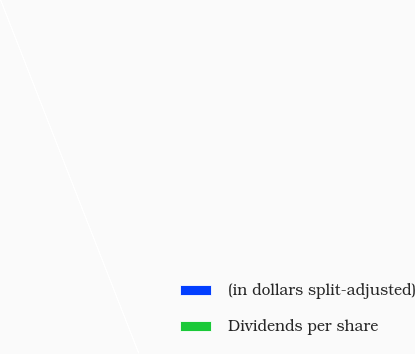<chart> <loc_0><loc_0><loc_500><loc_500><pie_chart><fcel>(in dollars split-adjusted)<fcel>Dividends per share<nl><fcel>100.0%<fcel>0.0%<nl></chart> 